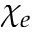<formula> <loc_0><loc_0><loc_500><loc_500>\chi _ { e }</formula> 